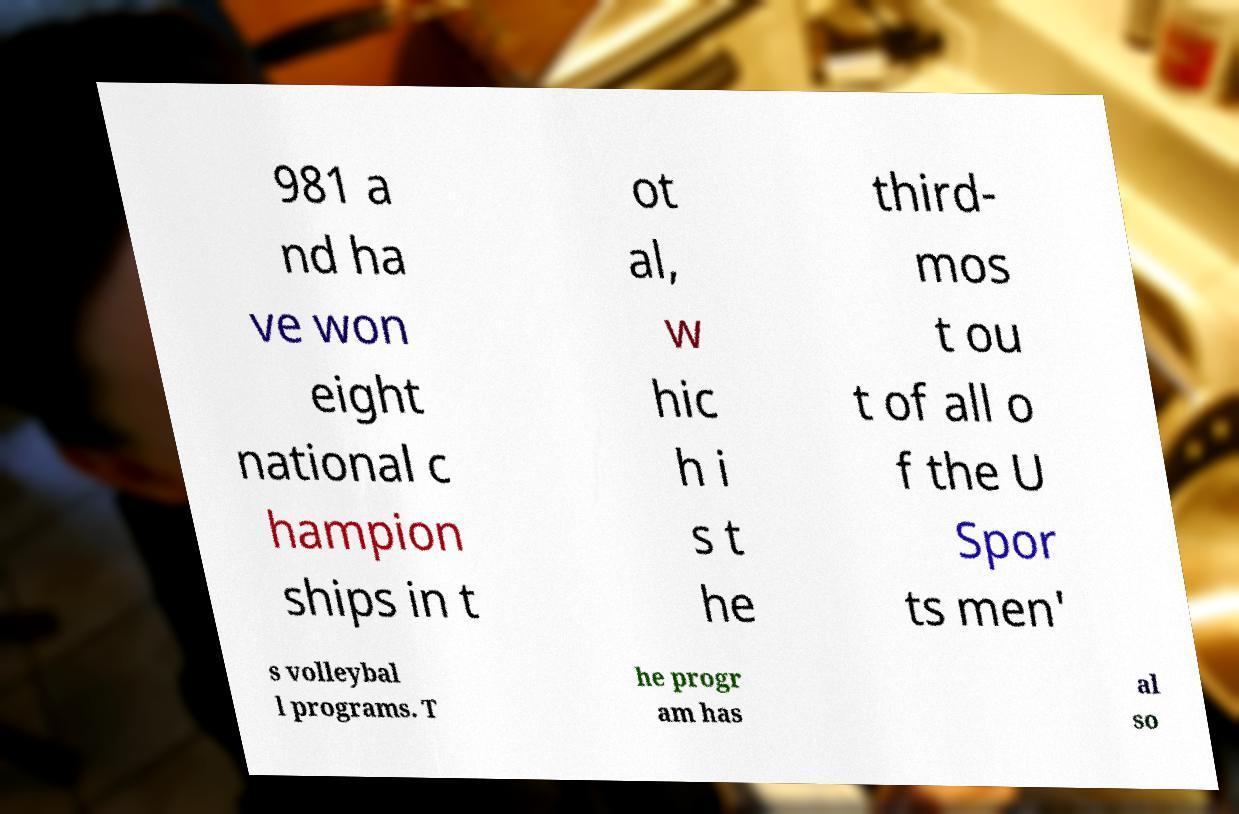Can you read and provide the text displayed in the image?This photo seems to have some interesting text. Can you extract and type it out for me? 981 a nd ha ve won eight national c hampion ships in t ot al, w hic h i s t he third- mos t ou t of all o f the U Spor ts men' s volleybal l programs. T he progr am has al so 